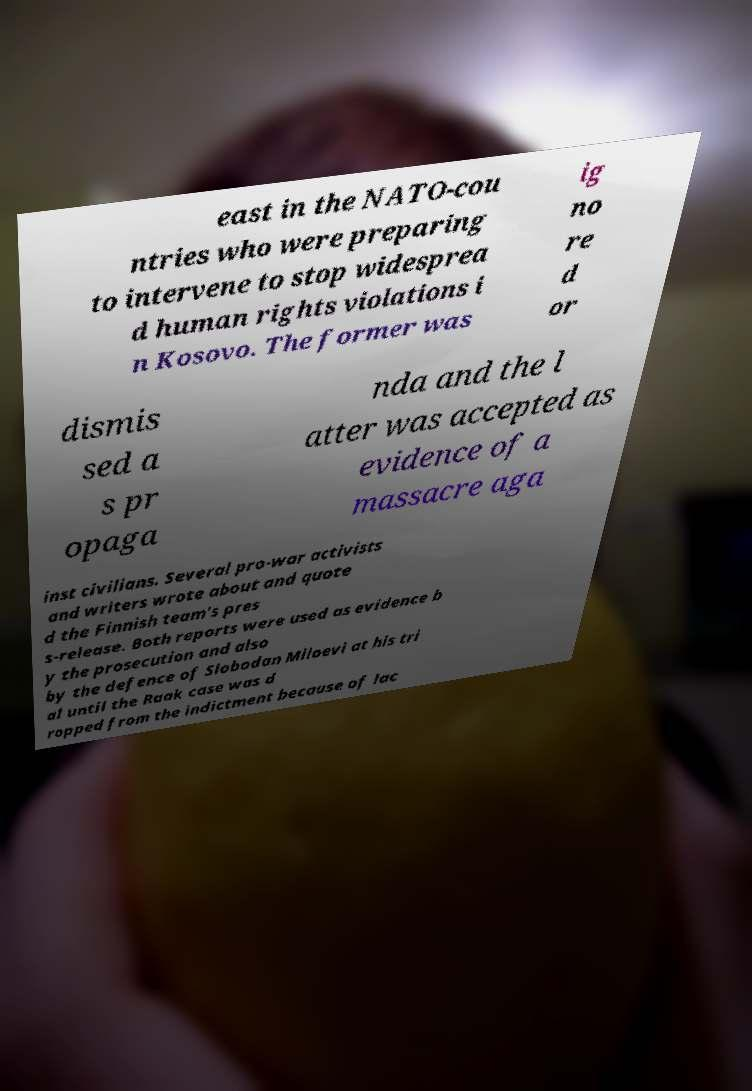Could you extract and type out the text from this image? east in the NATO-cou ntries who were preparing to intervene to stop widesprea d human rights violations i n Kosovo. The former was ig no re d or dismis sed a s pr opaga nda and the l atter was accepted as evidence of a massacre aga inst civilians. Several pro-war activists and writers wrote about and quote d the Finnish team's pres s-release. Both reports were used as evidence b y the prosecution and also by the defence of Slobodan Miloevi at his tri al until the Raak case was d ropped from the indictment because of lac 